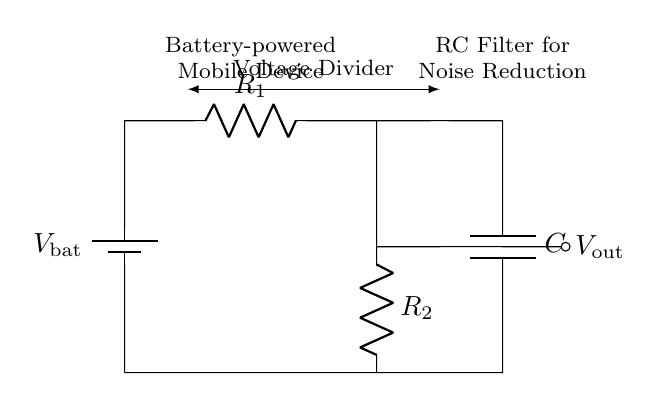What is the source voltage in this circuit? The source voltage is represented by the battery labeled V_bat. It is the voltage supplied to the circuit from the battery.
Answer: V_bat What are the resistances present in the circuit? The circuit includes two resistors labeled R_1 and R_2. These resistors are arranged in series as part of the voltage divider configuration.
Answer: R_1 and R_2 What is the role of the capacitor in this circuit? The capacitor labeled C functions as a filter to reduce noise from the voltage output. This helps to smooth out the voltage signal coming from the voltage divider.
Answer: Noise reduction How does the voltage output relate to the resistors in this circuit? The output voltage V_out is influenced by the values of R_1 and R_2, following the voltage divider rule, which states that the output voltage is a fraction of the input voltage based on these resistances.
Answer: Voltage divider rule If R_1 is 1kΩ and R_2 is 2kΩ, what is the ratio of V_out to V_bat? To find the ratio, use the voltage divider formula: V_out/V_bat = R_2 / (R_1 + R_2). Plugging in the values gives 2 / 3.
Answer: Two-thirds What type of circuit is represented in this diagram? This is a resistor-capacitor circuit, characterized by a voltage divider created by resistors and a capacitor used for filtering.
Answer: Resistor-capacitor circuit 